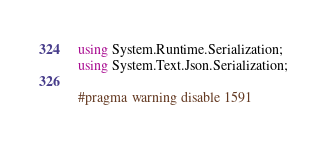<code> <loc_0><loc_0><loc_500><loc_500><_C#_>using System.Runtime.Serialization;
using System.Text.Json.Serialization;

#pragma warning disable 1591
</code> 